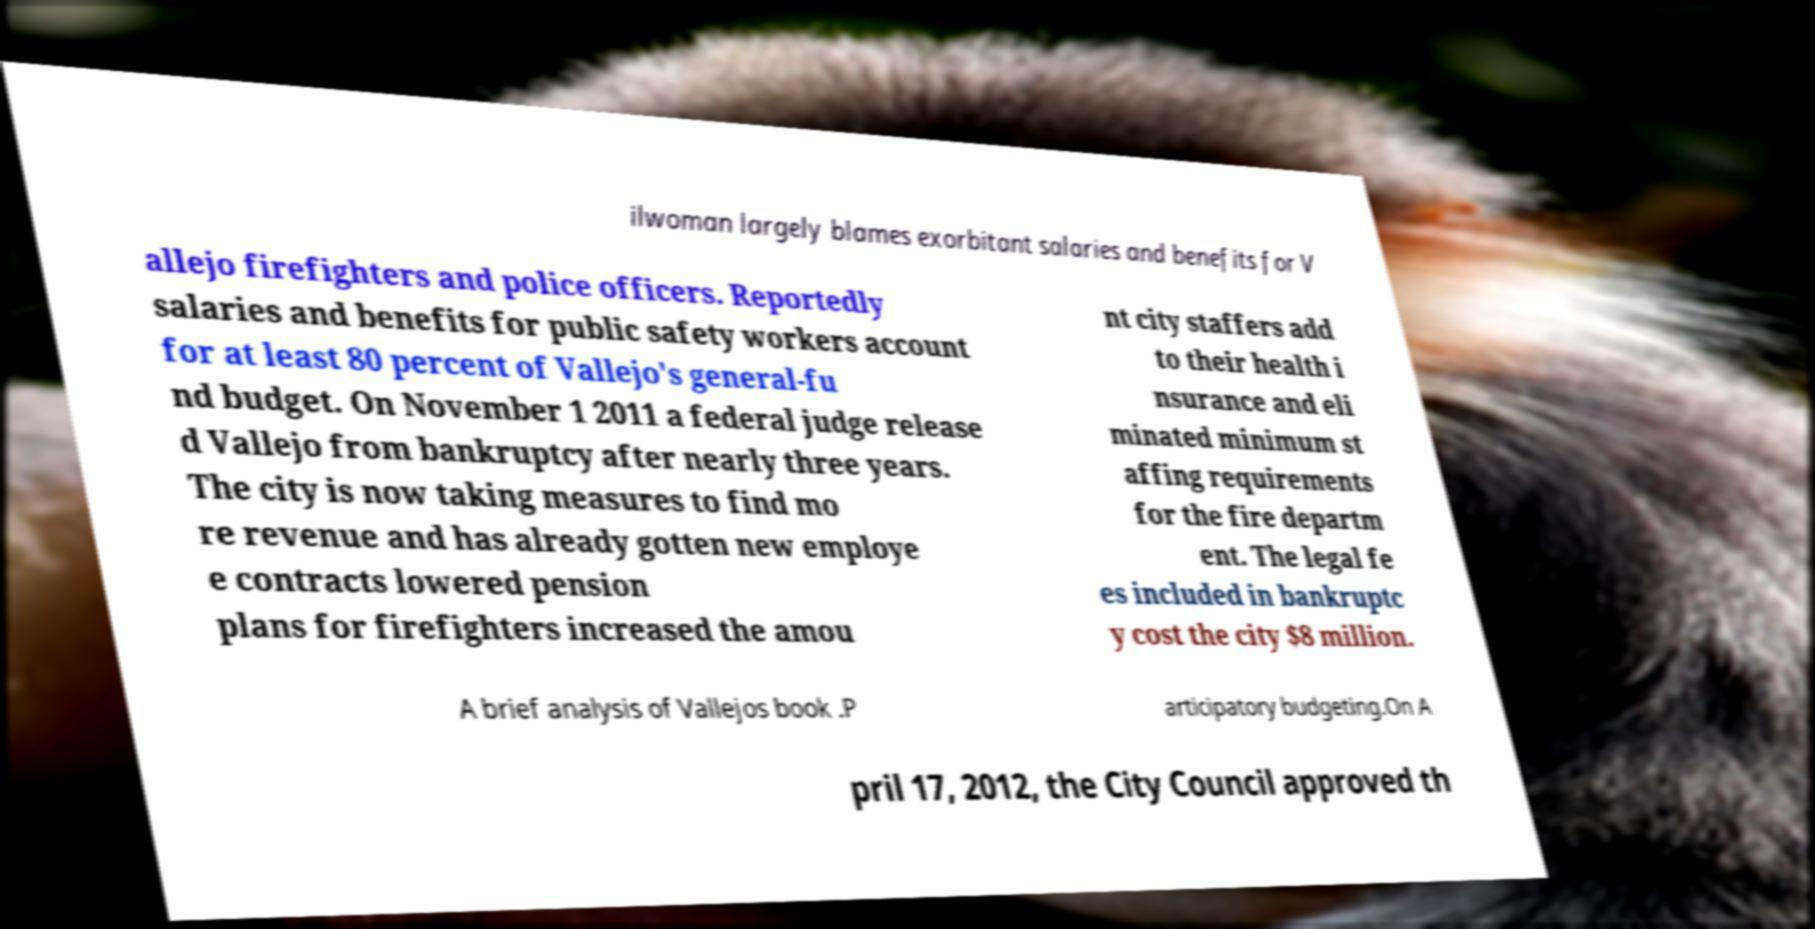Can you accurately transcribe the text from the provided image for me? ilwoman largely blames exorbitant salaries and benefits for V allejo firefighters and police officers. Reportedly salaries and benefits for public safety workers account for at least 80 percent of Vallejo's general-fu nd budget. On November 1 2011 a federal judge release d Vallejo from bankruptcy after nearly three years. The city is now taking measures to find mo re revenue and has already gotten new employe e contracts lowered pension plans for firefighters increased the amou nt city staffers add to their health i nsurance and eli minated minimum st affing requirements for the fire departm ent. The legal fe es included in bankruptc y cost the city $8 million. A brief analysis of Vallejos book .P articipatory budgeting.On A pril 17, 2012, the City Council approved th 